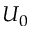<formula> <loc_0><loc_0><loc_500><loc_500>U _ { 0 }</formula> 